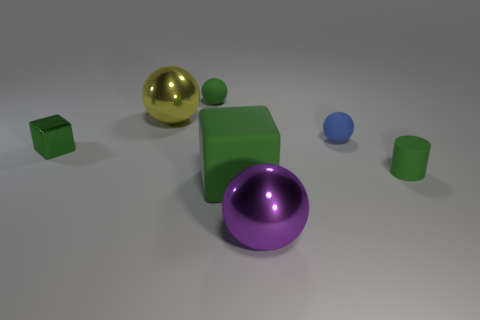Does the tiny metal block have the same color as the small cylinder?
Provide a succinct answer. Yes. What material is the small sphere that is the same color as the big rubber block?
Your answer should be very brief. Rubber. Is the number of large metal things right of the tiny matte cylinder greater than the number of purple shiny objects?
Keep it short and to the point. No. The sphere that is to the left of the tiny rubber thing that is to the left of the blue rubber sphere is what color?
Offer a very short reply. Yellow. How many green cubes are there?
Make the answer very short. 2. What number of tiny objects are right of the green sphere and behind the green shiny object?
Provide a succinct answer. 1. Are there any other things that are the same shape as the large green matte object?
Offer a very short reply. Yes. There is a tiny rubber cylinder; does it have the same color as the big shiny thing that is on the right side of the big yellow metal ball?
Your answer should be compact. No. The small green object that is behind the large yellow ball has what shape?
Your answer should be very brief. Sphere. What number of other objects are the same material as the small cylinder?
Make the answer very short. 3. 